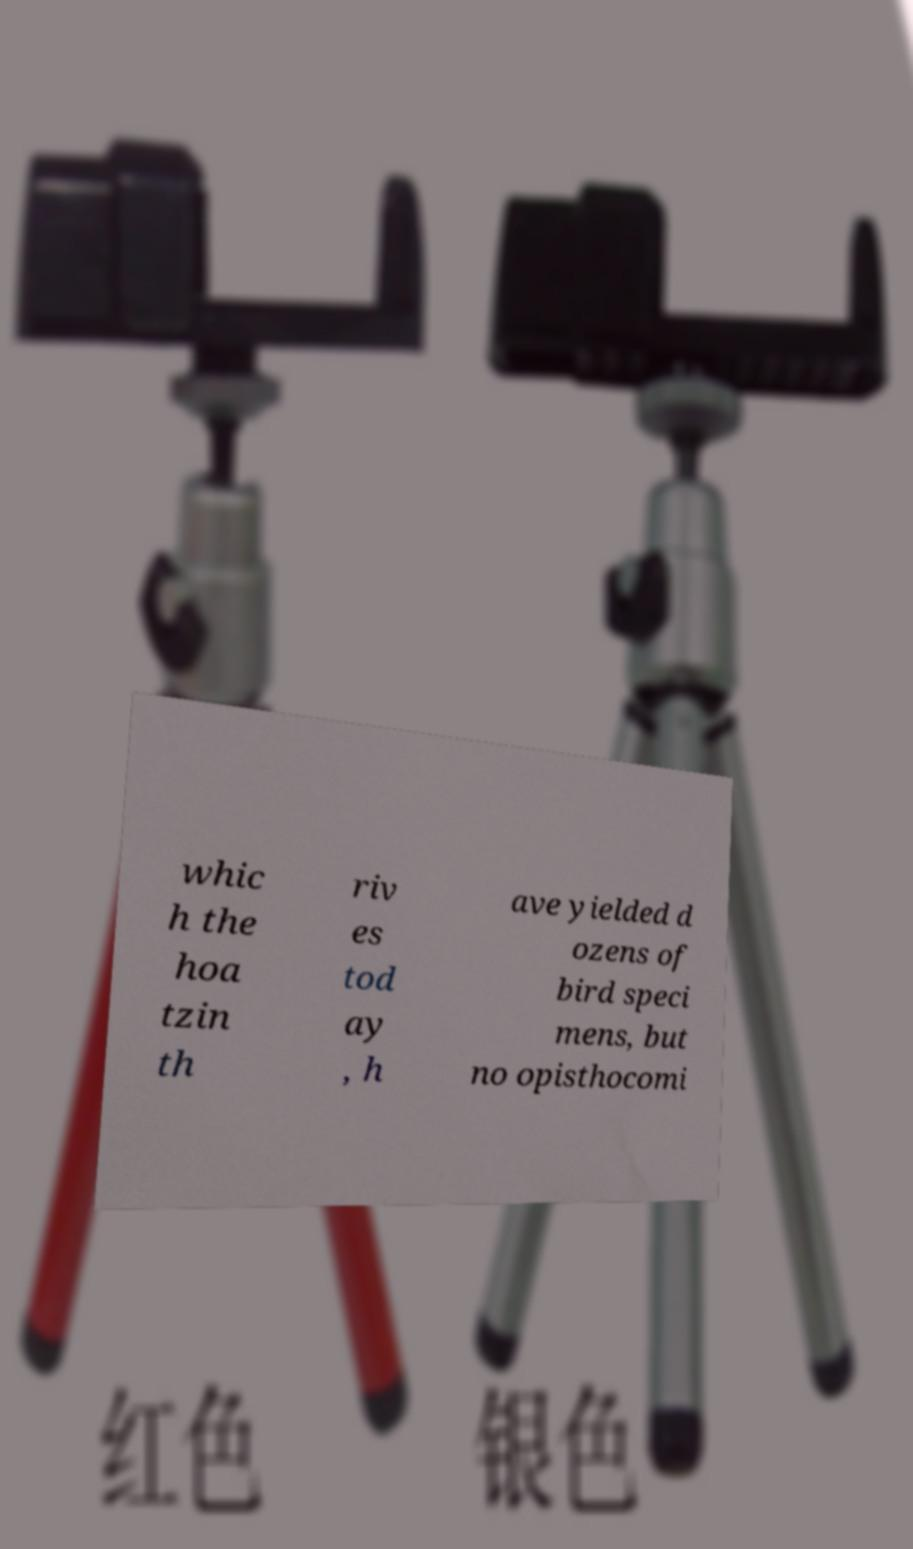I need the written content from this picture converted into text. Can you do that? whic h the hoa tzin th riv es tod ay , h ave yielded d ozens of bird speci mens, but no opisthocomi 